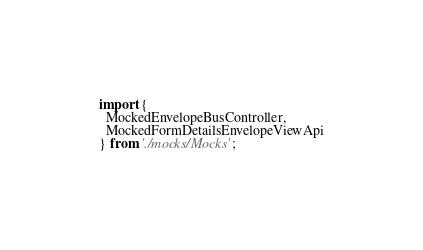Convert code to text. <code><loc_0><loc_0><loc_500><loc_500><_TypeScript_>import {
  MockedEnvelopeBusController,
  MockedFormDetailsEnvelopeViewApi
} from './mocks/Mocks';</code> 